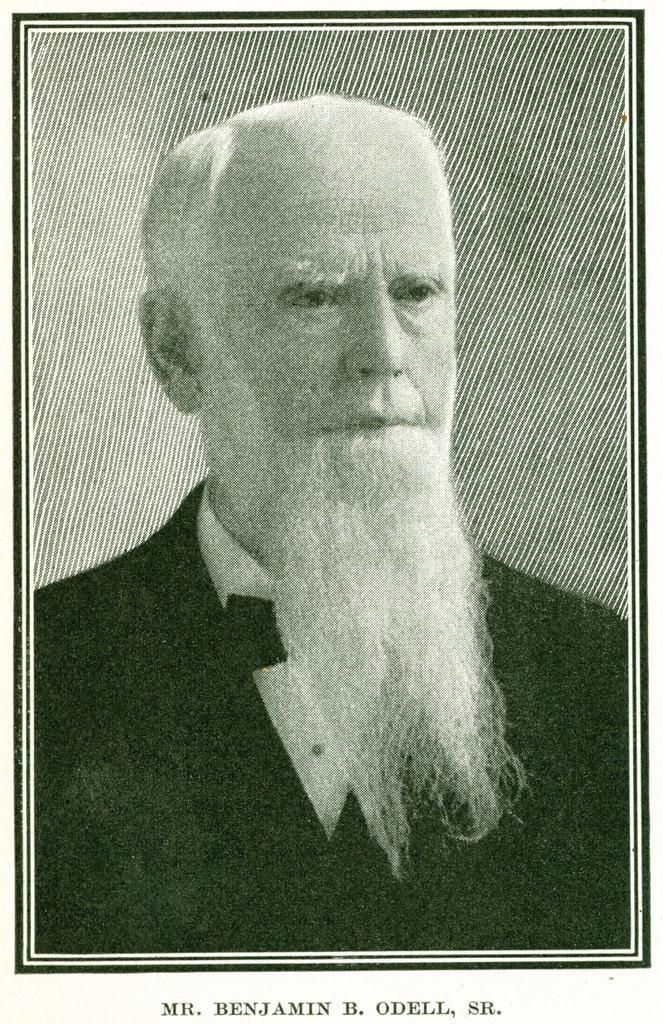In one or two sentences, can you explain what this image depicts? Picture of a person. Something written on this picture. 